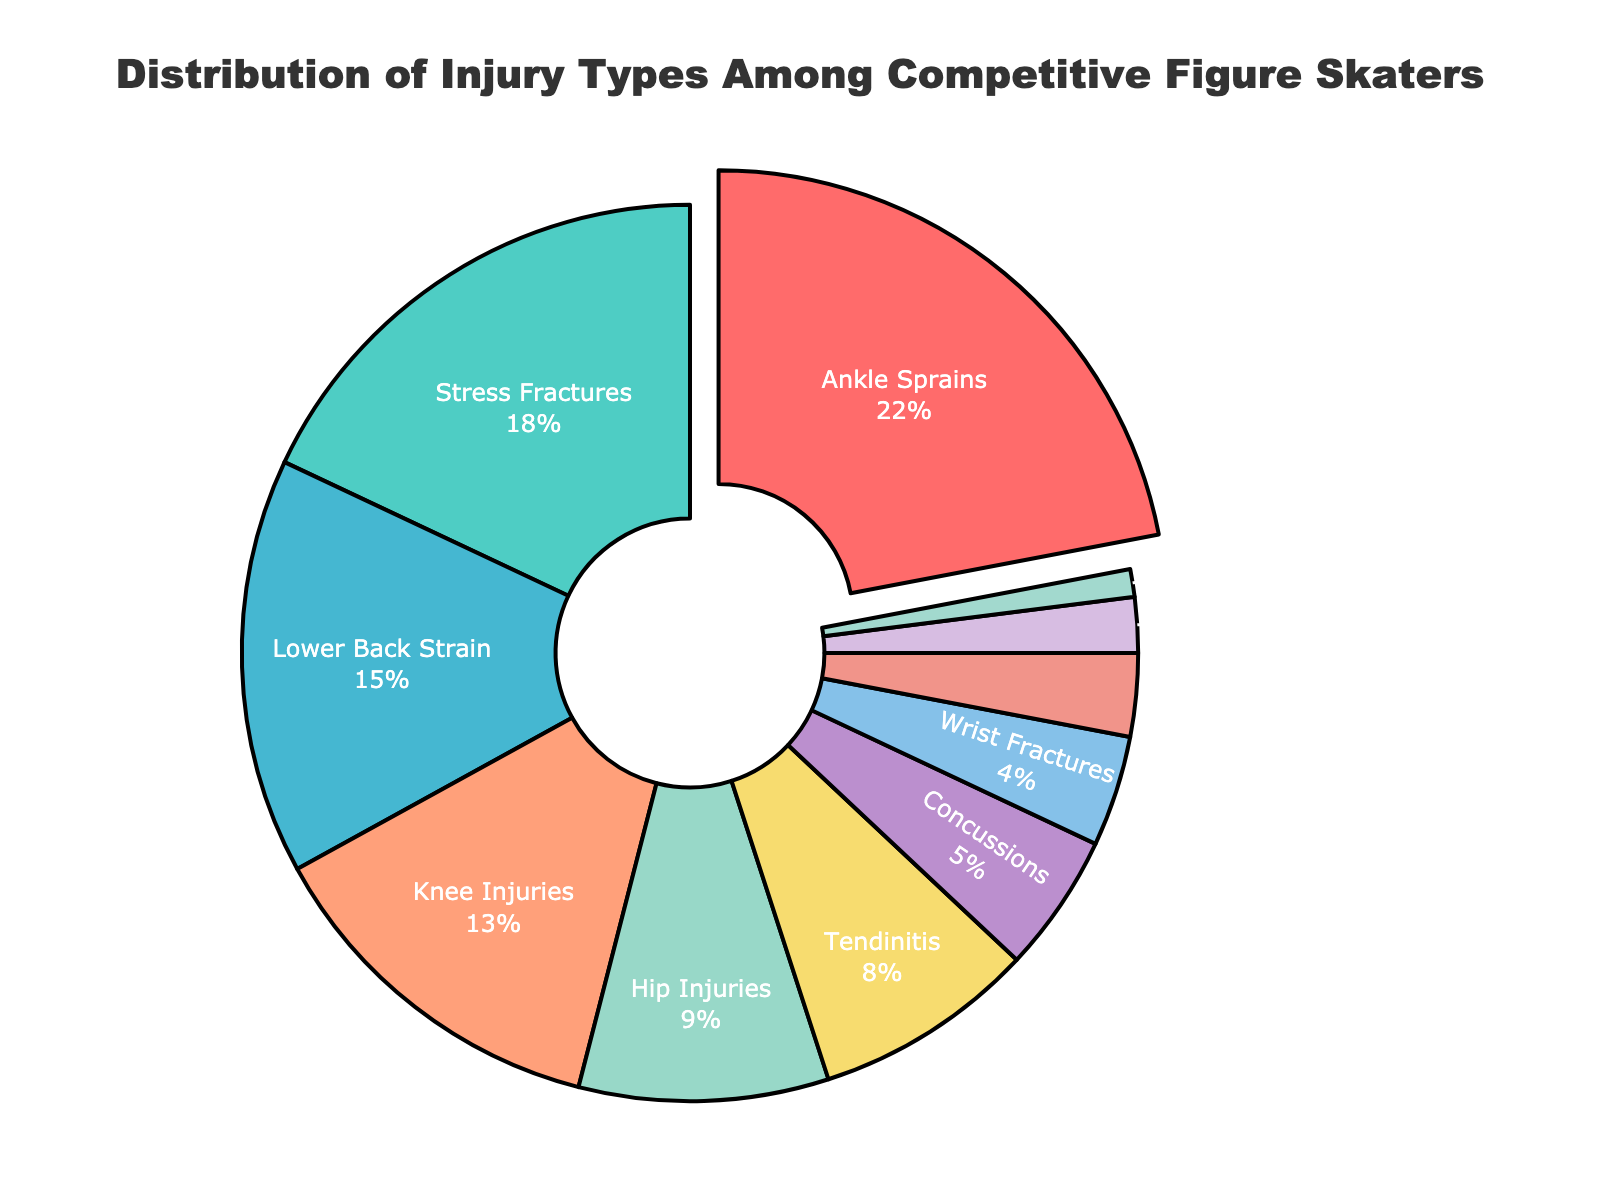What is the most common type of injury among competitive figure skaters? By examining the pie chart, it is clear that "Ankle Sprains" have the largest slice, indicating it is the most common type of injury.
Answer: Ankle Sprains Which injury type is less frequent than concussions but more frequent than wrist fractures? Looking at the pie chart, "Tendinitis" has a higher percentage than "Wrist Fractures" but less than "Concussions".
Answer: Tendinitis What is the combined percentage of knee injuries and hip injuries? Adding the percentages from the pie chart: 13% for knee injuries and 9% for hip injuries, the total is 13 + 9 = 22%.
Answer: 22% Which two injury types together make up the same percentage of the total as ankle sprains alone? Ankle Sprains make up 22%. Knee Injuries (13%) and Hip Injuries (9%) together also make up 22%.
Answer: Knee Injuries and Hip Injuries How much more frequent are stress fractures compared to shoulder injuries? Stress Fractures have 18% and Shoulder Injuries have 3%; the difference is 18% - 3% = 15%.
Answer: 15% Which injury type is represented by the color blue in the pie chart? According to the color scheme given in the data, "Lower Back Strain" is represented by the color blue.
Answer: Lower Back Strain What is the total percentage shared by the three least common injury types? Adding the percentages of the three least common injury types: Shoulder Injuries (3%), Lacerations (2%), and Muscle Strains (1%); the total is 3 + 2 + 1 = 6%.
Answer: 6% Which injury has a percentage closest to the median value of all mentioned injuries? The sorted percentages are: 1%, 2%, 3%, 4%, 5%, 8%, 9%, 13%, 15%, 18%, 22%. The median is at the 6th value, which is 8% for Tendinitis.
Answer: Tendinitis Which injury type has a higher percentage, knee injuries or concussions? By looking at the pie chart, knee injuries have 13% while concussions have 5%; knee injuries are higher.
Answer: Knee Injuries How many injury types have a percentage greater than 10%? The pie chart shows "Ankle Sprains" (22%), "Stress Fractures" (18%), "Lower Back Strain" (15%), and "Knee Injuries" (13%) are all above 10%. That makes a total of four.
Answer: 4 